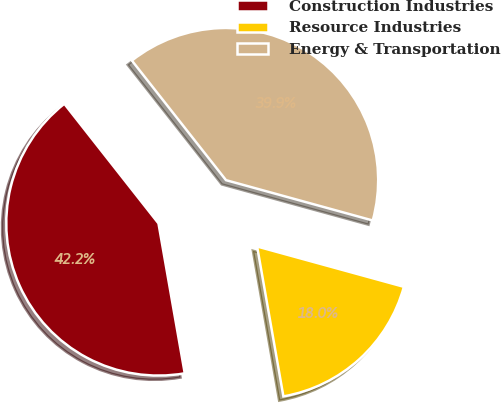Convert chart to OTSL. <chart><loc_0><loc_0><loc_500><loc_500><pie_chart><fcel>Construction Industries<fcel>Resource Industries<fcel>Energy & Transportation<nl><fcel>42.15%<fcel>17.97%<fcel>39.88%<nl></chart> 